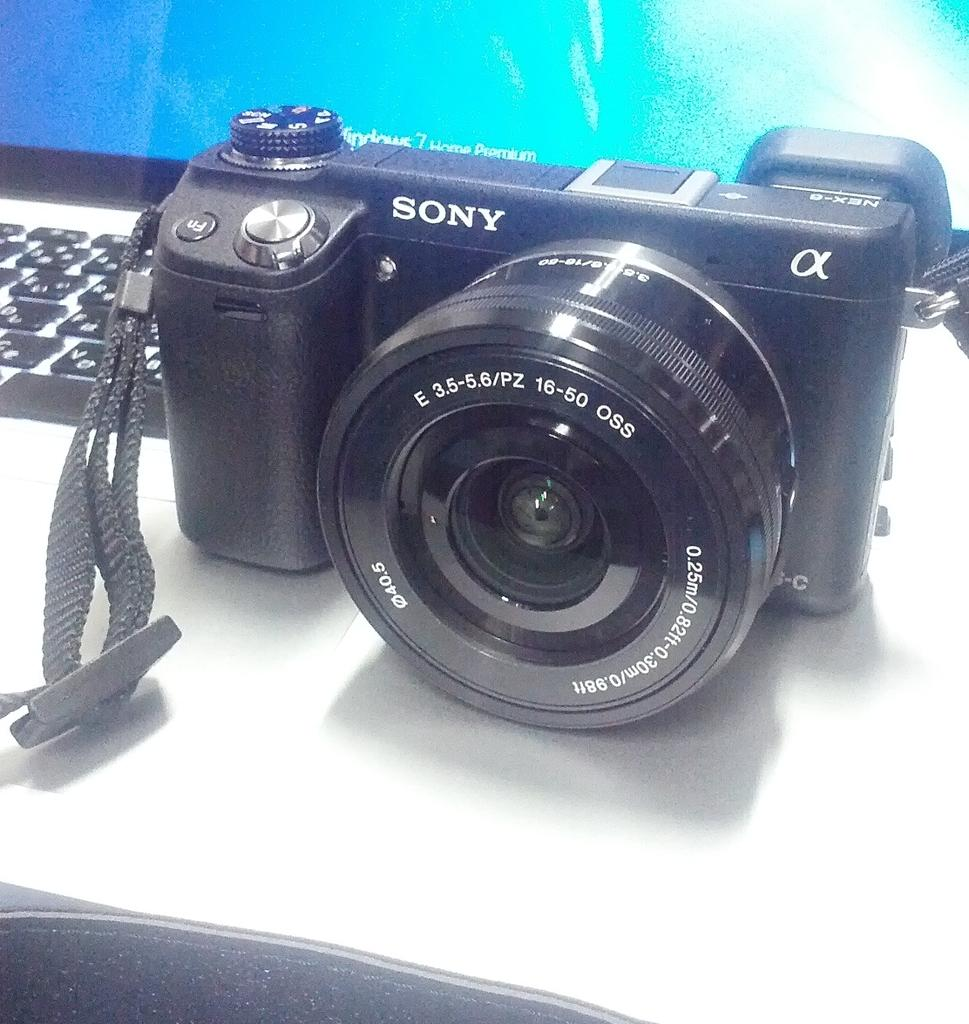What device is visible in the image? There is a camera in the image. Where is the camera located? The camera is on a laptop. What type of powder is being used to capture images on the moon in the image? There is no moon or powder present in the image; it only features a camera on a laptop. 